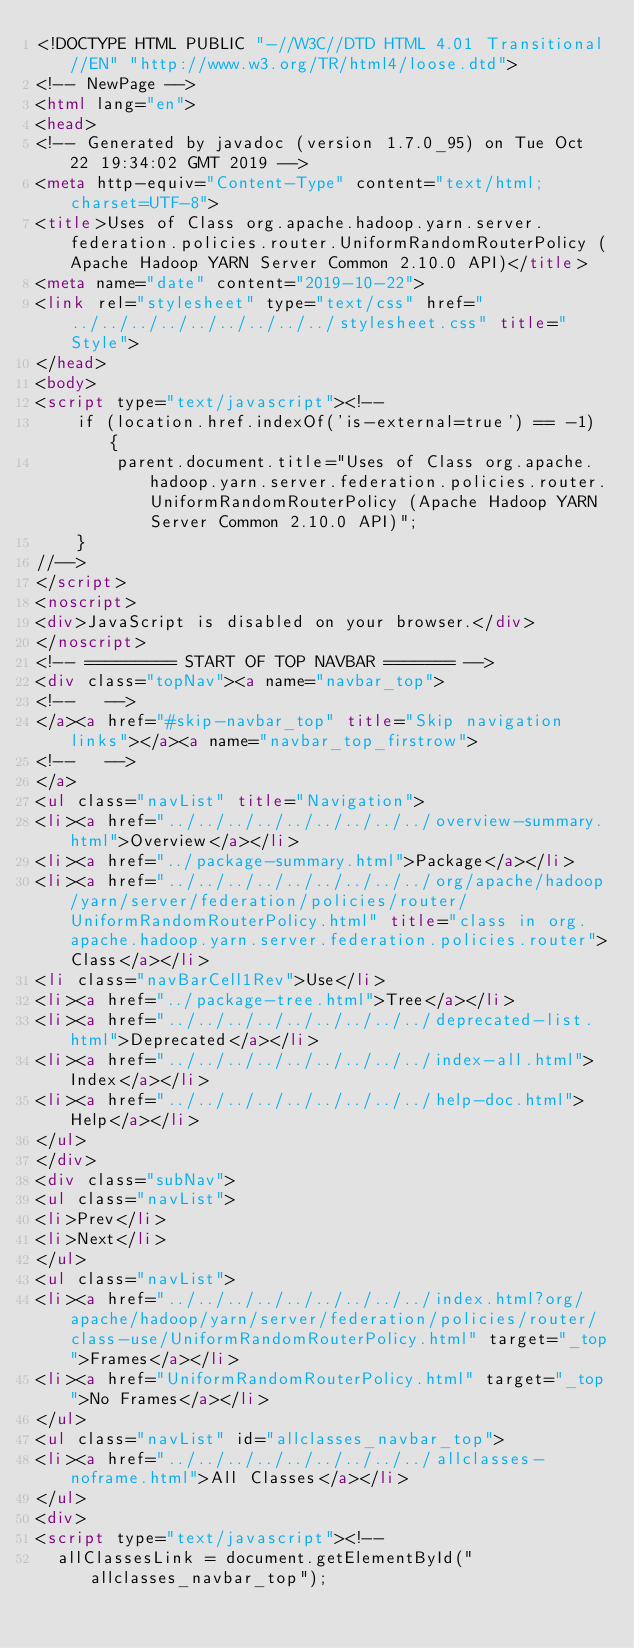Convert code to text. <code><loc_0><loc_0><loc_500><loc_500><_HTML_><!DOCTYPE HTML PUBLIC "-//W3C//DTD HTML 4.01 Transitional//EN" "http://www.w3.org/TR/html4/loose.dtd">
<!-- NewPage -->
<html lang="en">
<head>
<!-- Generated by javadoc (version 1.7.0_95) on Tue Oct 22 19:34:02 GMT 2019 -->
<meta http-equiv="Content-Type" content="text/html; charset=UTF-8">
<title>Uses of Class org.apache.hadoop.yarn.server.federation.policies.router.UniformRandomRouterPolicy (Apache Hadoop YARN Server Common 2.10.0 API)</title>
<meta name="date" content="2019-10-22">
<link rel="stylesheet" type="text/css" href="../../../../../../../../../stylesheet.css" title="Style">
</head>
<body>
<script type="text/javascript"><!--
    if (location.href.indexOf('is-external=true') == -1) {
        parent.document.title="Uses of Class org.apache.hadoop.yarn.server.federation.policies.router.UniformRandomRouterPolicy (Apache Hadoop YARN Server Common 2.10.0 API)";
    }
//-->
</script>
<noscript>
<div>JavaScript is disabled on your browser.</div>
</noscript>
<!-- ========= START OF TOP NAVBAR ======= -->
<div class="topNav"><a name="navbar_top">
<!--   -->
</a><a href="#skip-navbar_top" title="Skip navigation links"></a><a name="navbar_top_firstrow">
<!--   -->
</a>
<ul class="navList" title="Navigation">
<li><a href="../../../../../../../../../overview-summary.html">Overview</a></li>
<li><a href="../package-summary.html">Package</a></li>
<li><a href="../../../../../../../../../org/apache/hadoop/yarn/server/federation/policies/router/UniformRandomRouterPolicy.html" title="class in org.apache.hadoop.yarn.server.federation.policies.router">Class</a></li>
<li class="navBarCell1Rev">Use</li>
<li><a href="../package-tree.html">Tree</a></li>
<li><a href="../../../../../../../../../deprecated-list.html">Deprecated</a></li>
<li><a href="../../../../../../../../../index-all.html">Index</a></li>
<li><a href="../../../../../../../../../help-doc.html">Help</a></li>
</ul>
</div>
<div class="subNav">
<ul class="navList">
<li>Prev</li>
<li>Next</li>
</ul>
<ul class="navList">
<li><a href="../../../../../../../../../index.html?org/apache/hadoop/yarn/server/federation/policies/router/class-use/UniformRandomRouterPolicy.html" target="_top">Frames</a></li>
<li><a href="UniformRandomRouterPolicy.html" target="_top">No Frames</a></li>
</ul>
<ul class="navList" id="allclasses_navbar_top">
<li><a href="../../../../../../../../../allclasses-noframe.html">All Classes</a></li>
</ul>
<div>
<script type="text/javascript"><!--
  allClassesLink = document.getElementById("allclasses_navbar_top");</code> 